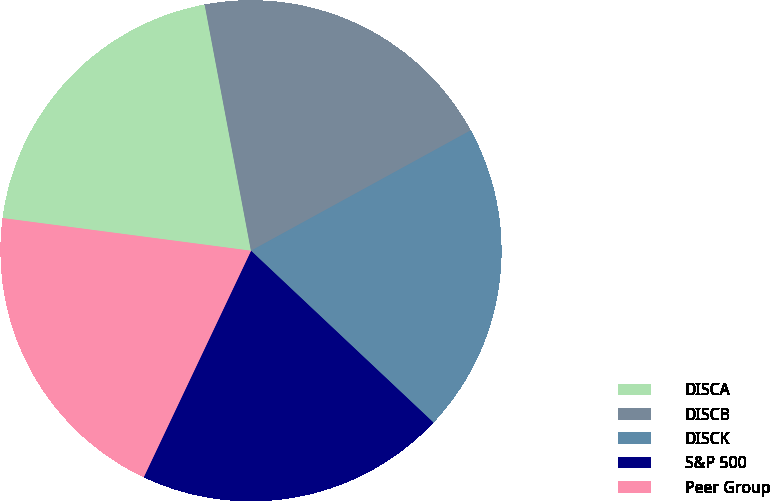Convert chart to OTSL. <chart><loc_0><loc_0><loc_500><loc_500><pie_chart><fcel>DISCA<fcel>DISCB<fcel>DISCK<fcel>S&P 500<fcel>Peer Group<nl><fcel>19.96%<fcel>19.98%<fcel>20.0%<fcel>20.02%<fcel>20.04%<nl></chart> 